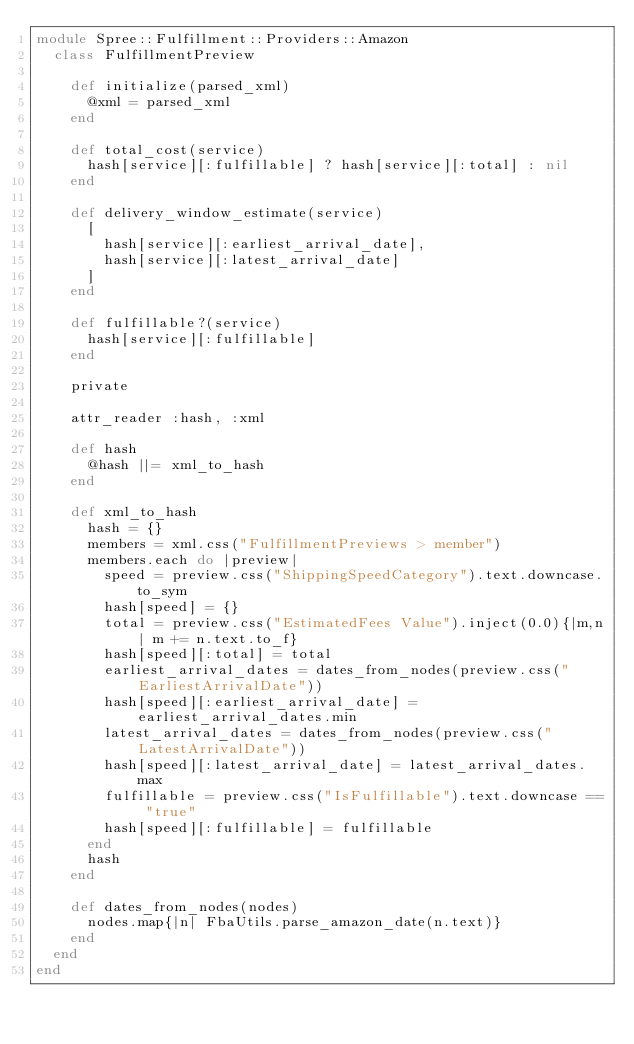Convert code to text. <code><loc_0><loc_0><loc_500><loc_500><_Ruby_>module Spree::Fulfillment::Providers::Amazon
  class FulfillmentPreview

    def initialize(parsed_xml)
      @xml = parsed_xml
    end

    def total_cost(service)
      hash[service][:fulfillable] ? hash[service][:total] : nil
    end

    def delivery_window_estimate(service)
      [
        hash[service][:earliest_arrival_date],
        hash[service][:latest_arrival_date]
      ]
    end

    def fulfillable?(service)
      hash[service][:fulfillable]
    end

    private

    attr_reader :hash, :xml

    def hash
      @hash ||= xml_to_hash
    end

    def xml_to_hash
      hash = {}
      members = xml.css("FulfillmentPreviews > member")
      members.each do |preview|
        speed = preview.css("ShippingSpeedCategory").text.downcase.to_sym
        hash[speed] = {}
        total = preview.css("EstimatedFees Value").inject(0.0){|m,n| m += n.text.to_f}
        hash[speed][:total] = total
        earliest_arrival_dates = dates_from_nodes(preview.css("EarliestArrivalDate"))
        hash[speed][:earliest_arrival_date] = earliest_arrival_dates.min
        latest_arrival_dates = dates_from_nodes(preview.css("LatestArrivalDate"))
        hash[speed][:latest_arrival_date] = latest_arrival_dates.max
        fulfillable = preview.css("IsFulfillable").text.downcase == "true"
        hash[speed][:fulfillable] = fulfillable
      end
      hash
    end

    def dates_from_nodes(nodes)
      nodes.map{|n| FbaUtils.parse_amazon_date(n.text)}
    end
  end
end</code> 